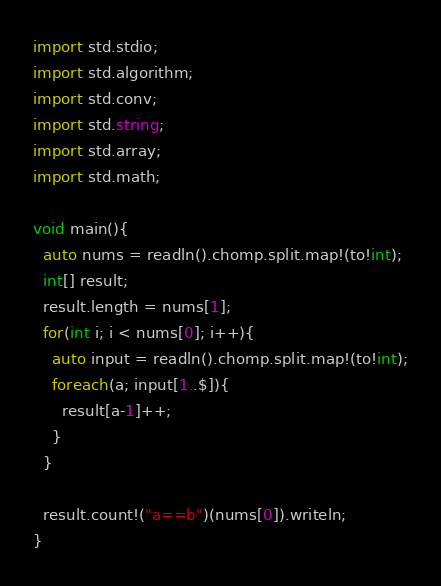<code> <loc_0><loc_0><loc_500><loc_500><_D_>import std.stdio;
import std.algorithm;
import std.conv;
import std.string;
import std.array;
import std.math;

void main(){
  auto nums = readln().chomp.split.map!(to!int);
  int[] result;
  result.length = nums[1];
  for(int i; i < nums[0]; i++){
    auto input = readln().chomp.split.map!(to!int);
    foreach(a; input[1..$]){
      result[a-1]++;
    }
  }

  result.count!("a==b")(nums[0]).writeln;
}</code> 